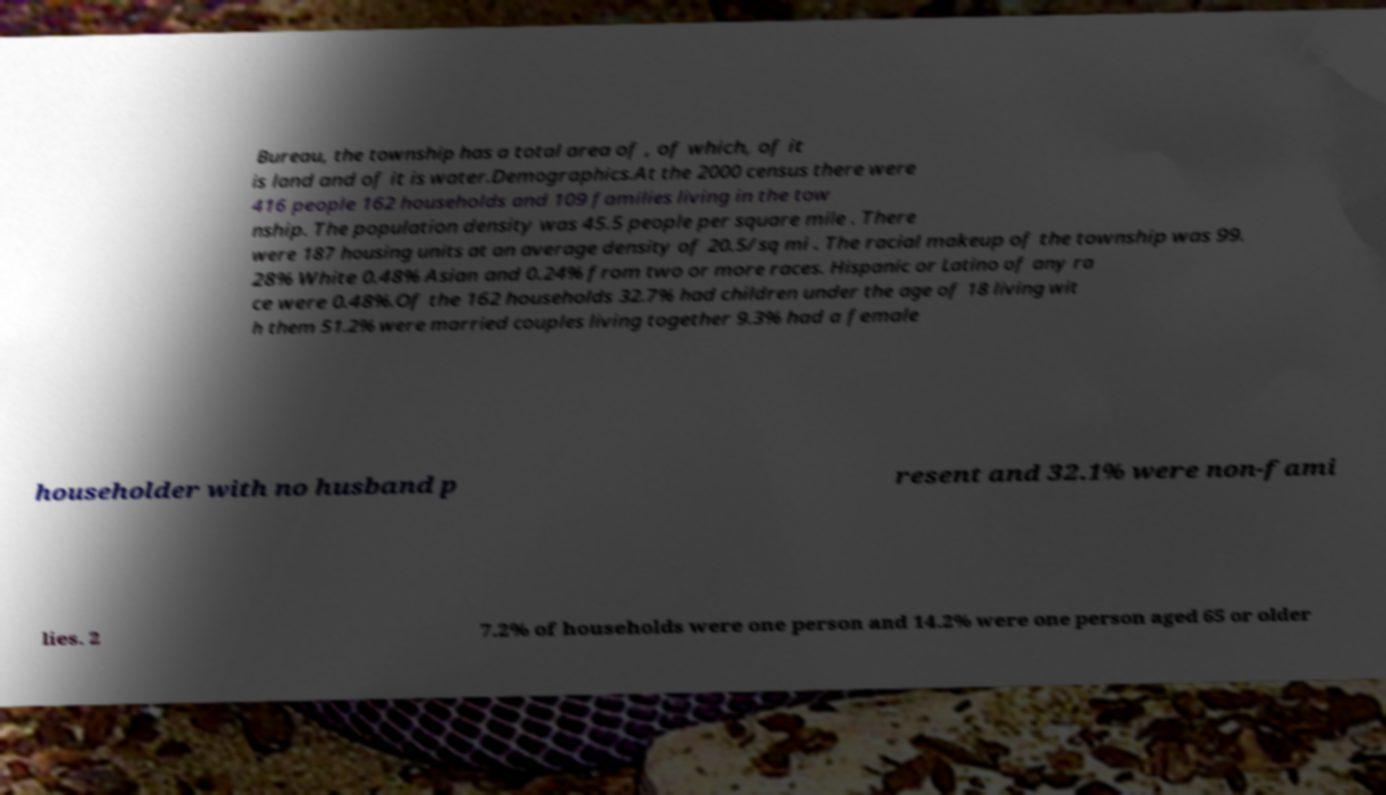Please read and relay the text visible in this image. What does it say? Bureau, the township has a total area of , of which, of it is land and of it is water.Demographics.At the 2000 census there were 416 people 162 households and 109 families living in the tow nship. The population density was 45.5 people per square mile . There were 187 housing units at an average density of 20.5/sq mi . The racial makeup of the township was 99. 28% White 0.48% Asian and 0.24% from two or more races. Hispanic or Latino of any ra ce were 0.48%.Of the 162 households 32.7% had children under the age of 18 living wit h them 51.2% were married couples living together 9.3% had a female householder with no husband p resent and 32.1% were non-fami lies. 2 7.2% of households were one person and 14.2% were one person aged 65 or older 